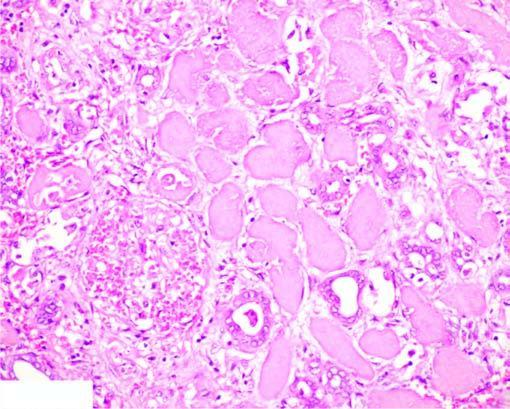does the show non-specific chronic inflammation and proliferating vessels?
Answer the question using a single word or phrase. No 